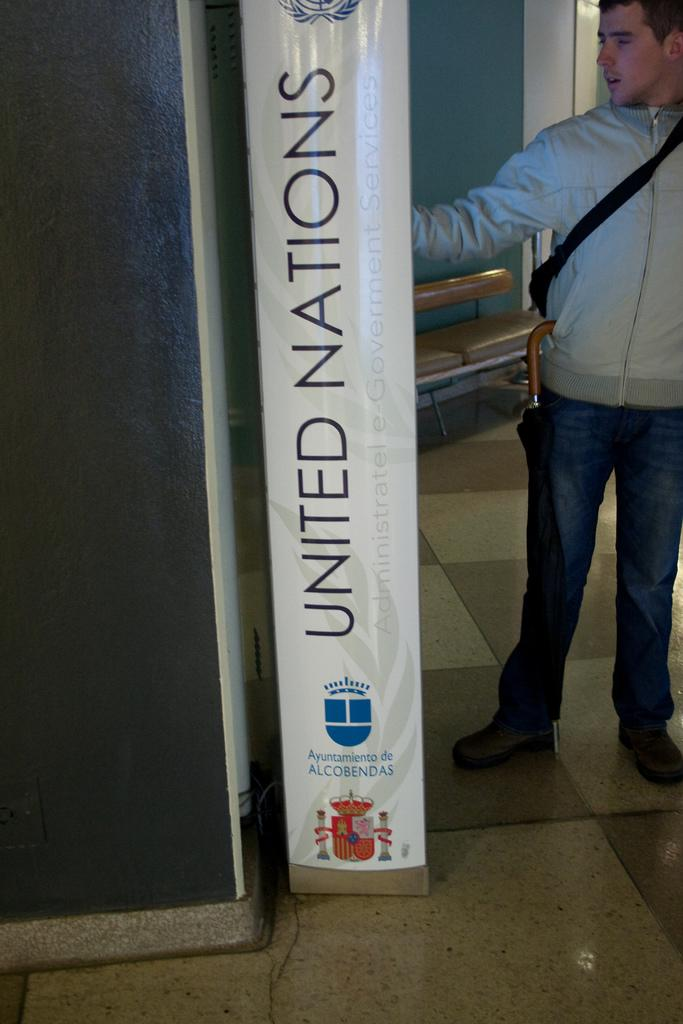<image>
Give a short and clear explanation of the subsequent image. Man standing next to a white sign that says "United Nations". 